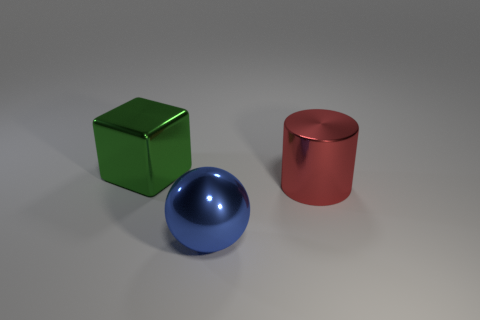Add 1 large blue matte cubes. How many objects exist? 4 Subtract all cylinders. How many objects are left? 2 Subtract all metallic cubes. Subtract all red things. How many objects are left? 1 Add 3 blue metal spheres. How many blue metal spheres are left? 4 Add 2 large green metallic cubes. How many large green metallic cubes exist? 3 Subtract 0 yellow spheres. How many objects are left? 3 